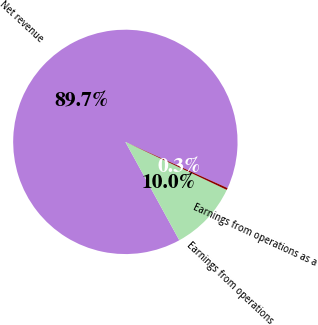<chart> <loc_0><loc_0><loc_500><loc_500><pie_chart><fcel>Net revenue<fcel>Earnings from operations<fcel>Earnings from operations as a<nl><fcel>89.74%<fcel>9.98%<fcel>0.28%<nl></chart> 